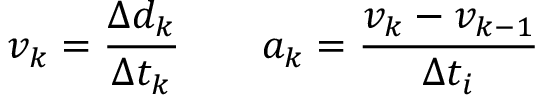<formula> <loc_0><loc_0><loc_500><loc_500>v _ { k } = \frac { \Delta { d } _ { k } } { \Delta { t } _ { k } } \quad a _ { k } = \frac { v _ { k } - v _ { k - 1 } } { \Delta t _ { i } }</formula> 